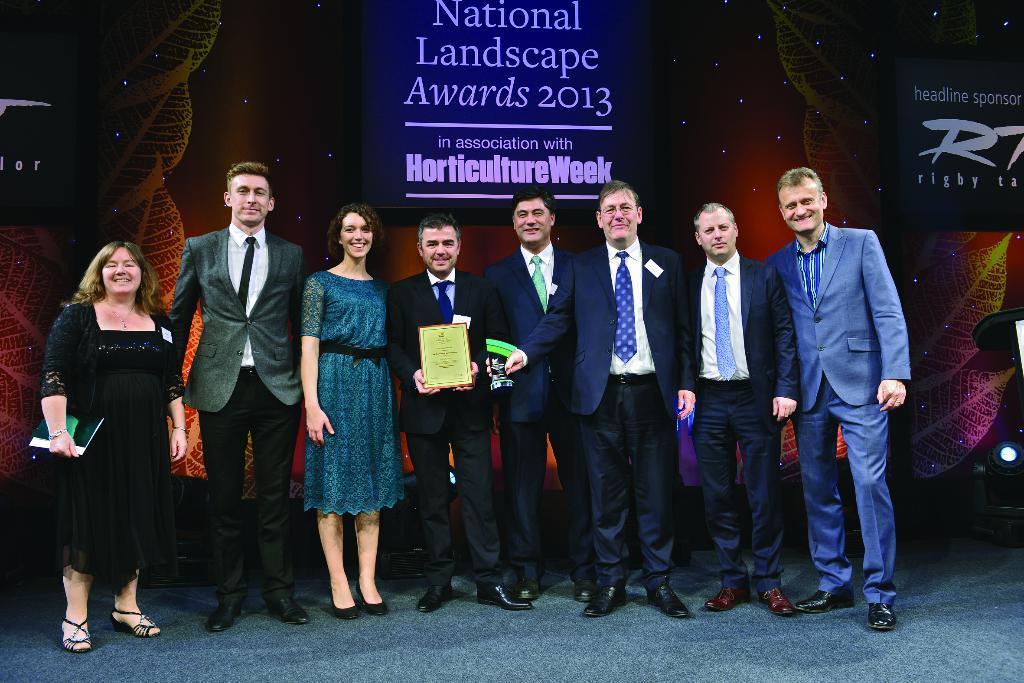Please provide a concise description of this image. In this image we can see the persons standing on the floor and one of them is holding a certificate in his hand. In the background there is an advertisement. 